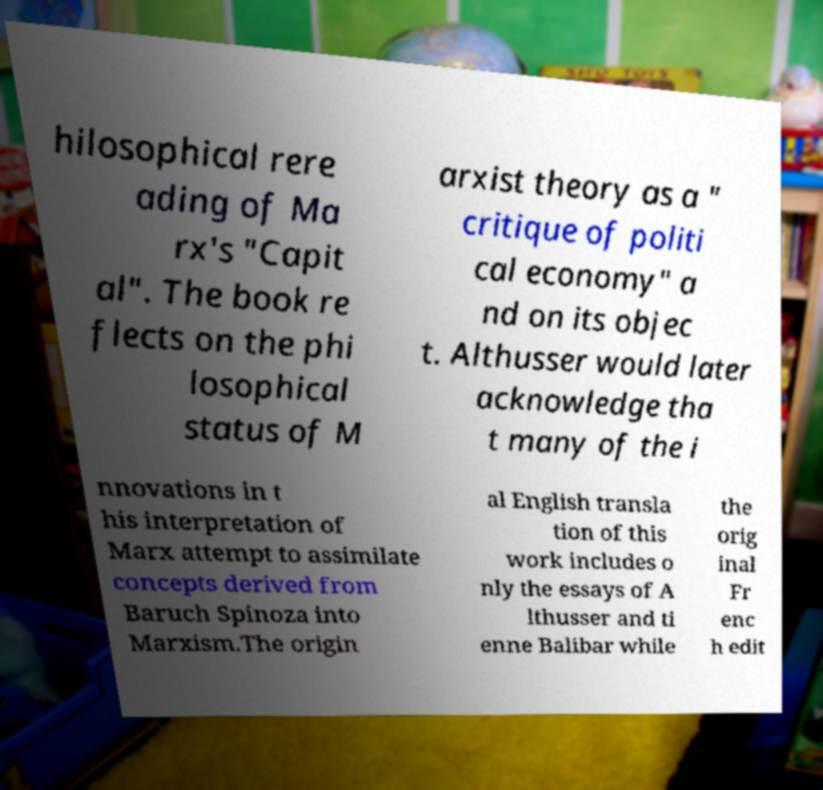I need the written content from this picture converted into text. Can you do that? hilosophical rere ading of Ma rx's "Capit al". The book re flects on the phi losophical status of M arxist theory as a " critique of politi cal economy" a nd on its objec t. Althusser would later acknowledge tha t many of the i nnovations in t his interpretation of Marx attempt to assimilate concepts derived from Baruch Spinoza into Marxism.The origin al English transla tion of this work includes o nly the essays of A lthusser and ti enne Balibar while the orig inal Fr enc h edit 